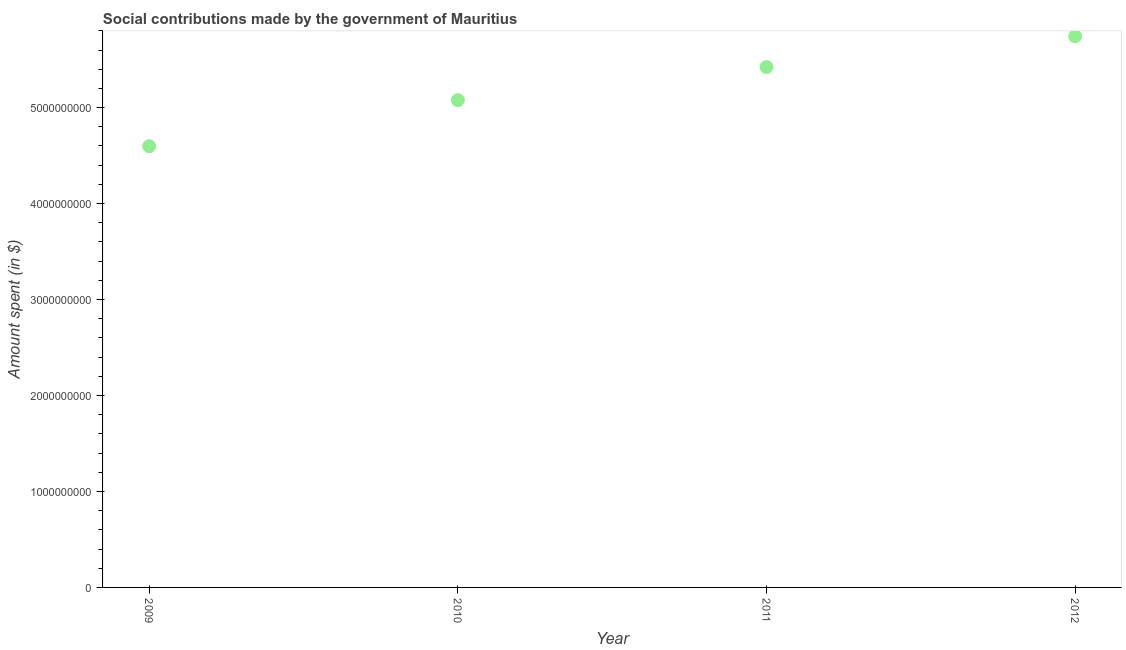What is the amount spent in making social contributions in 2011?
Offer a very short reply. 5.42e+09. Across all years, what is the maximum amount spent in making social contributions?
Ensure brevity in your answer.  5.74e+09. Across all years, what is the minimum amount spent in making social contributions?
Make the answer very short. 4.60e+09. In which year was the amount spent in making social contributions maximum?
Ensure brevity in your answer.  2012. In which year was the amount spent in making social contributions minimum?
Make the answer very short. 2009. What is the sum of the amount spent in making social contributions?
Make the answer very short. 2.08e+1. What is the difference between the amount spent in making social contributions in 2010 and 2012?
Provide a short and direct response. -6.65e+08. What is the average amount spent in making social contributions per year?
Provide a succinct answer. 5.21e+09. What is the median amount spent in making social contributions?
Ensure brevity in your answer.  5.25e+09. What is the ratio of the amount spent in making social contributions in 2011 to that in 2012?
Give a very brief answer. 0.94. Is the amount spent in making social contributions in 2009 less than that in 2011?
Provide a short and direct response. Yes. Is the difference between the amount spent in making social contributions in 2010 and 2011 greater than the difference between any two years?
Your answer should be compact. No. What is the difference between the highest and the second highest amount spent in making social contributions?
Your answer should be compact. 3.21e+08. Is the sum of the amount spent in making social contributions in 2010 and 2012 greater than the maximum amount spent in making social contributions across all years?
Offer a terse response. Yes. What is the difference between the highest and the lowest amount spent in making social contributions?
Make the answer very short. 1.15e+09. How many years are there in the graph?
Ensure brevity in your answer.  4. What is the difference between two consecutive major ticks on the Y-axis?
Offer a terse response. 1.00e+09. Does the graph contain any zero values?
Offer a very short reply. No. Does the graph contain grids?
Offer a terse response. No. What is the title of the graph?
Your answer should be compact. Social contributions made by the government of Mauritius. What is the label or title of the X-axis?
Make the answer very short. Year. What is the label or title of the Y-axis?
Provide a succinct answer. Amount spent (in $). What is the Amount spent (in $) in 2009?
Your answer should be very brief. 4.60e+09. What is the Amount spent (in $) in 2010?
Offer a terse response. 5.08e+09. What is the Amount spent (in $) in 2011?
Offer a very short reply. 5.42e+09. What is the Amount spent (in $) in 2012?
Your response must be concise. 5.74e+09. What is the difference between the Amount spent (in $) in 2009 and 2010?
Offer a very short reply. -4.80e+08. What is the difference between the Amount spent (in $) in 2009 and 2011?
Give a very brief answer. -8.24e+08. What is the difference between the Amount spent (in $) in 2009 and 2012?
Your answer should be very brief. -1.15e+09. What is the difference between the Amount spent (in $) in 2010 and 2011?
Make the answer very short. -3.45e+08. What is the difference between the Amount spent (in $) in 2010 and 2012?
Give a very brief answer. -6.65e+08. What is the difference between the Amount spent (in $) in 2011 and 2012?
Make the answer very short. -3.21e+08. What is the ratio of the Amount spent (in $) in 2009 to that in 2010?
Make the answer very short. 0.91. What is the ratio of the Amount spent (in $) in 2009 to that in 2011?
Your answer should be very brief. 0.85. What is the ratio of the Amount spent (in $) in 2009 to that in 2012?
Give a very brief answer. 0.8. What is the ratio of the Amount spent (in $) in 2010 to that in 2011?
Your answer should be compact. 0.94. What is the ratio of the Amount spent (in $) in 2010 to that in 2012?
Provide a short and direct response. 0.88. What is the ratio of the Amount spent (in $) in 2011 to that in 2012?
Provide a short and direct response. 0.94. 